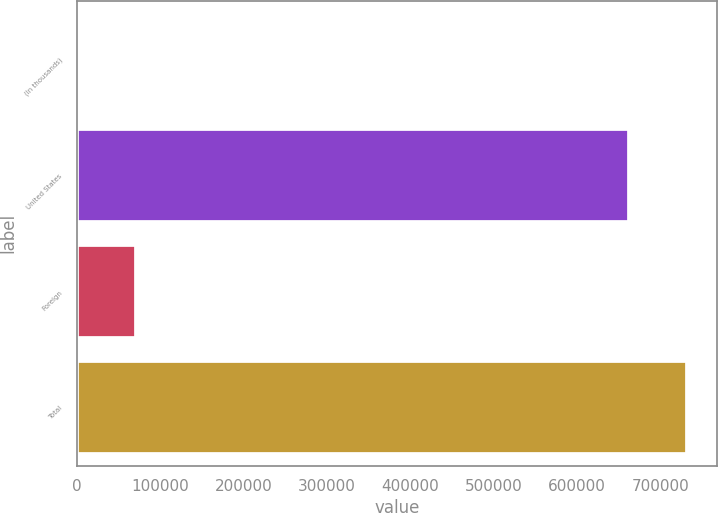Convert chart. <chart><loc_0><loc_0><loc_500><loc_500><bar_chart><fcel>(In thousands)<fcel>United States<fcel>Foreign<fcel>Total<nl><fcel>2007<fcel>661966<fcel>71447.5<fcel>731406<nl></chart> 